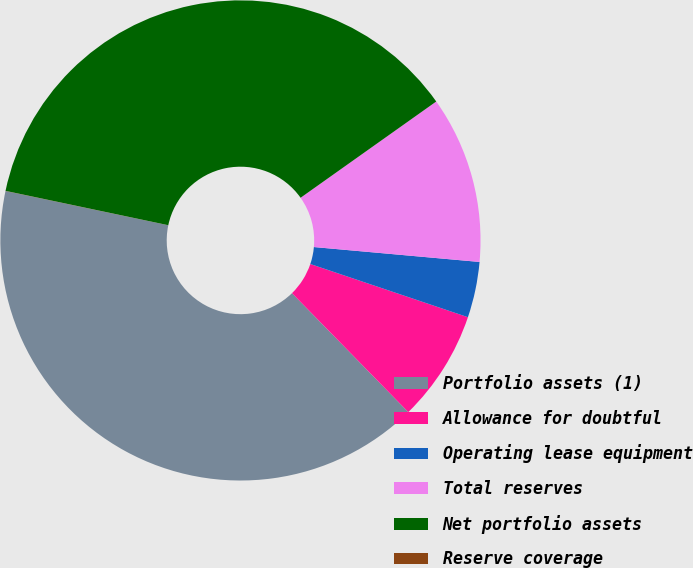Convert chart. <chart><loc_0><loc_0><loc_500><loc_500><pie_chart><fcel>Portfolio assets (1)<fcel>Allowance for doubtful<fcel>Operating lease equipment<fcel>Total reserves<fcel>Net portfolio assets<fcel>Reserve coverage<nl><fcel>40.62%<fcel>7.5%<fcel>3.75%<fcel>11.25%<fcel>36.87%<fcel>0.01%<nl></chart> 